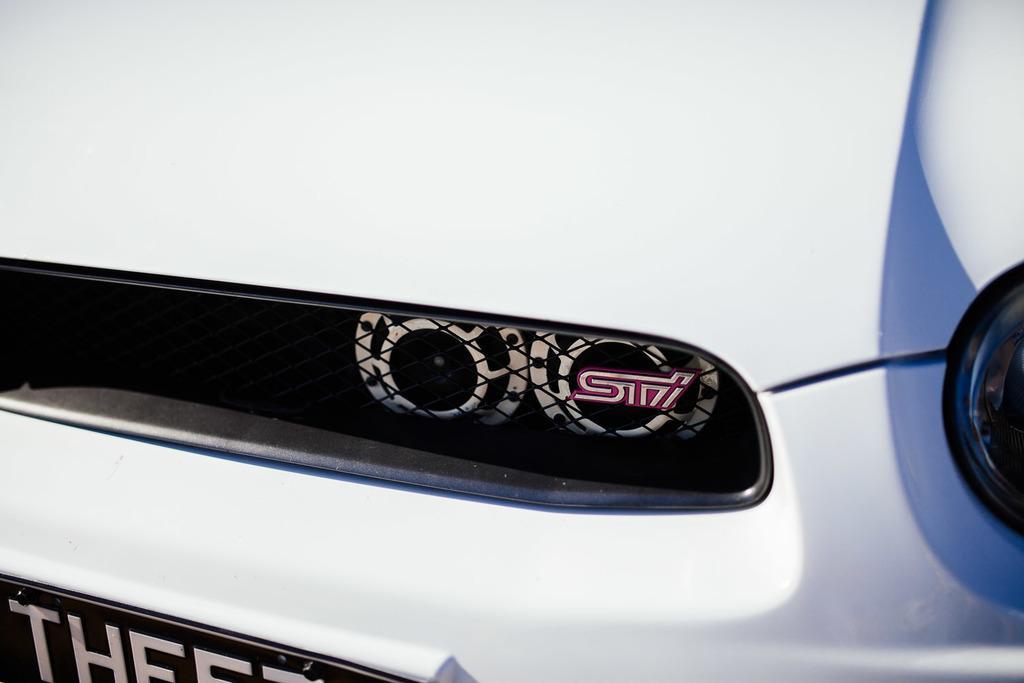Could you give a brief overview of what you see in this image? In this image the front part of the car is clicked. At the bottom there is text on the number plate. To the right there are headlights. 